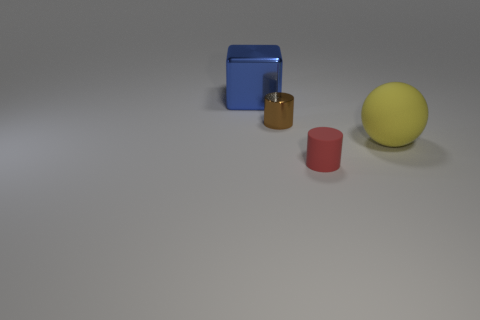What is the size of the object that is to the right of the thing in front of the large thing that is in front of the big blue block?
Provide a succinct answer. Large. What number of big cubes are made of the same material as the brown object?
Provide a short and direct response. 1. The rubber object left of the large thing that is on the right side of the large blue cube is what color?
Offer a terse response. Red. How many objects are either big metal things or things to the right of the block?
Give a very brief answer. 4. What number of blue objects are either metallic cubes or small cylinders?
Provide a succinct answer. 1. What number of other objects are the same size as the red cylinder?
Offer a terse response. 1. What number of big things are blue cylinders or brown shiny things?
Keep it short and to the point. 0. There is a sphere; does it have the same size as the rubber thing that is in front of the large yellow sphere?
Your answer should be compact. No. How many other things are the same shape as the brown thing?
Your answer should be compact. 1. There is a tiny object that is the same material as the yellow ball; what shape is it?
Offer a very short reply. Cylinder. 